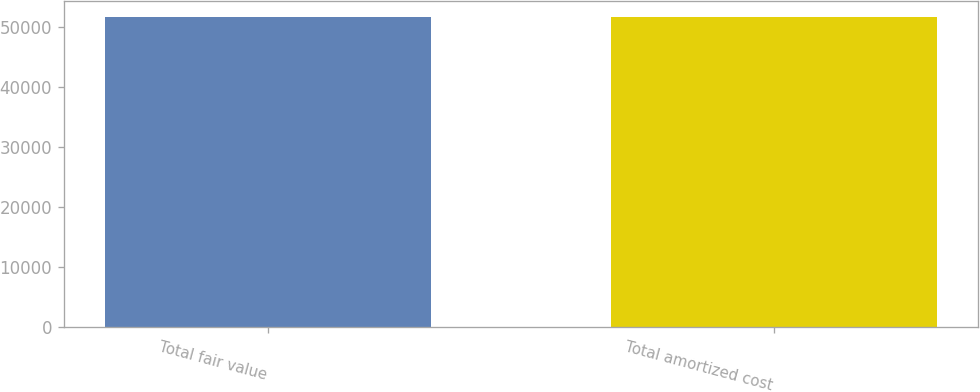<chart> <loc_0><loc_0><loc_500><loc_500><bar_chart><fcel>Total fair value<fcel>Total amortized cost<nl><fcel>51618<fcel>51604<nl></chart> 